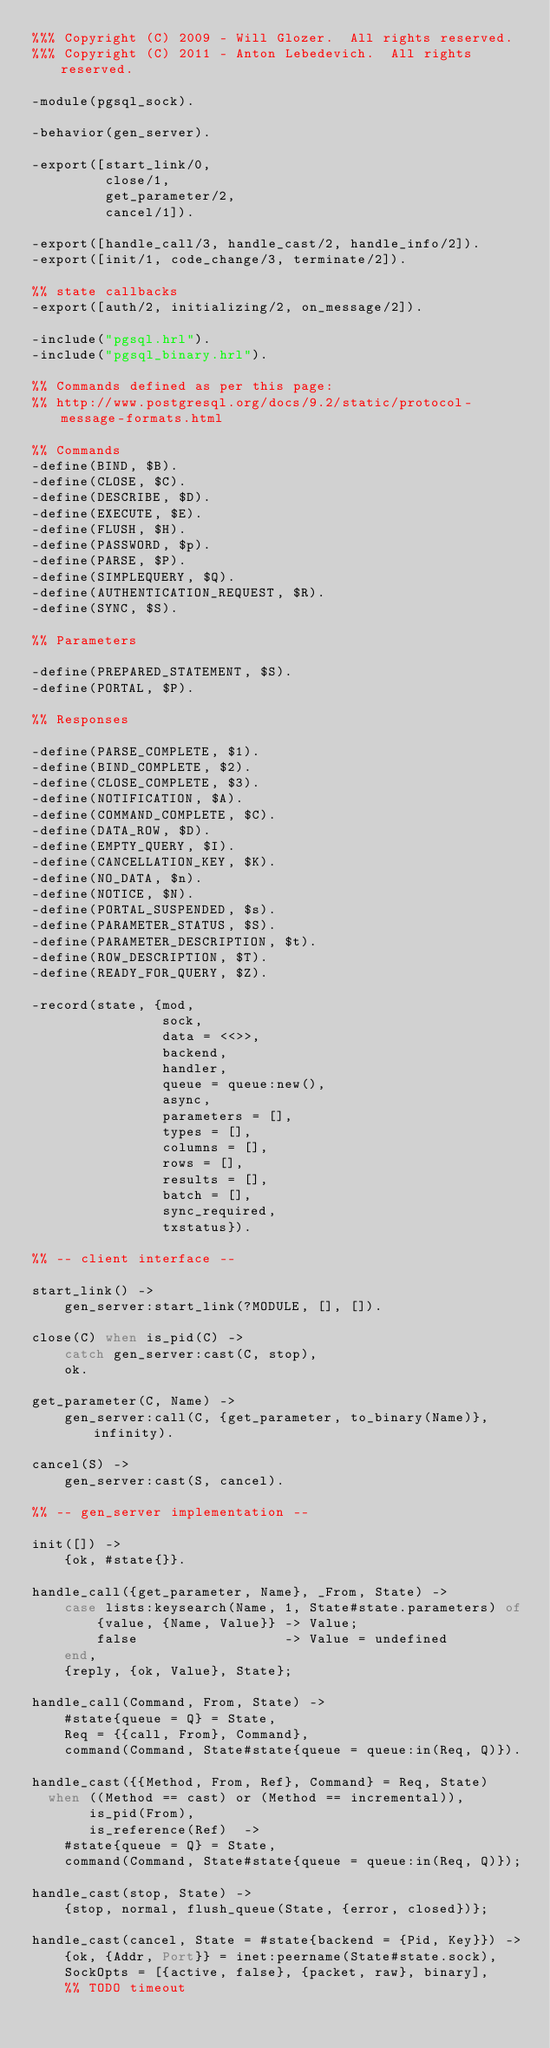<code> <loc_0><loc_0><loc_500><loc_500><_Erlang_>%%% Copyright (C) 2009 - Will Glozer.  All rights reserved.
%%% Copyright (C) 2011 - Anton Lebedevich.  All rights reserved.

-module(pgsql_sock).

-behavior(gen_server).

-export([start_link/0,
         close/1,
         get_parameter/2,
         cancel/1]).

-export([handle_call/3, handle_cast/2, handle_info/2]).
-export([init/1, code_change/3, terminate/2]).

%% state callbacks
-export([auth/2, initializing/2, on_message/2]).

-include("pgsql.hrl").
-include("pgsql_binary.hrl").

%% Commands defined as per this page:
%% http://www.postgresql.org/docs/9.2/static/protocol-message-formats.html

%% Commands
-define(BIND, $B).
-define(CLOSE, $C).
-define(DESCRIBE, $D).
-define(EXECUTE, $E).
-define(FLUSH, $H).
-define(PASSWORD, $p).
-define(PARSE, $P).
-define(SIMPLEQUERY, $Q).
-define(AUTHENTICATION_REQUEST, $R).
-define(SYNC, $S).

%% Parameters

-define(PREPARED_STATEMENT, $S).
-define(PORTAL, $P).

%% Responses

-define(PARSE_COMPLETE, $1).
-define(BIND_COMPLETE, $2).
-define(CLOSE_COMPLETE, $3).
-define(NOTIFICATION, $A).
-define(COMMAND_COMPLETE, $C).
-define(DATA_ROW, $D).
-define(EMPTY_QUERY, $I).
-define(CANCELLATION_KEY, $K).
-define(NO_DATA, $n).
-define(NOTICE, $N).
-define(PORTAL_SUSPENDED, $s).
-define(PARAMETER_STATUS, $S).
-define(PARAMETER_DESCRIPTION, $t).
-define(ROW_DESCRIPTION, $T).
-define(READY_FOR_QUERY, $Z).

-record(state, {mod,
                sock,
                data = <<>>,
                backend,
                handler,
                queue = queue:new(),
                async,
                parameters = [],
                types = [],
                columns = [],
                rows = [],
                results = [],
                batch = [],
                sync_required,
                txstatus}).

%% -- client interface --

start_link() ->
    gen_server:start_link(?MODULE, [], []).

close(C) when is_pid(C) ->
    catch gen_server:cast(C, stop),
    ok.

get_parameter(C, Name) ->
    gen_server:call(C, {get_parameter, to_binary(Name)}, infinity).

cancel(S) ->
    gen_server:cast(S, cancel).

%% -- gen_server implementation --

init([]) ->
    {ok, #state{}}.

handle_call({get_parameter, Name}, _From, State) ->
    case lists:keysearch(Name, 1, State#state.parameters) of
        {value, {Name, Value}} -> Value;
        false                  -> Value = undefined
    end,
    {reply, {ok, Value}, State};

handle_call(Command, From, State) ->
    #state{queue = Q} = State,
    Req = {{call, From}, Command},
    command(Command, State#state{queue = queue:in(Req, Q)}).

handle_cast({{Method, From, Ref}, Command} = Req, State)
  when ((Method == cast) or (Method == incremental)),
       is_pid(From),
       is_reference(Ref)  ->
    #state{queue = Q} = State,
    command(Command, State#state{queue = queue:in(Req, Q)});

handle_cast(stop, State) ->
    {stop, normal, flush_queue(State, {error, closed})};

handle_cast(cancel, State = #state{backend = {Pid, Key}}) ->
    {ok, {Addr, Port}} = inet:peername(State#state.sock),
    SockOpts = [{active, false}, {packet, raw}, binary],
    %% TODO timeout</code> 